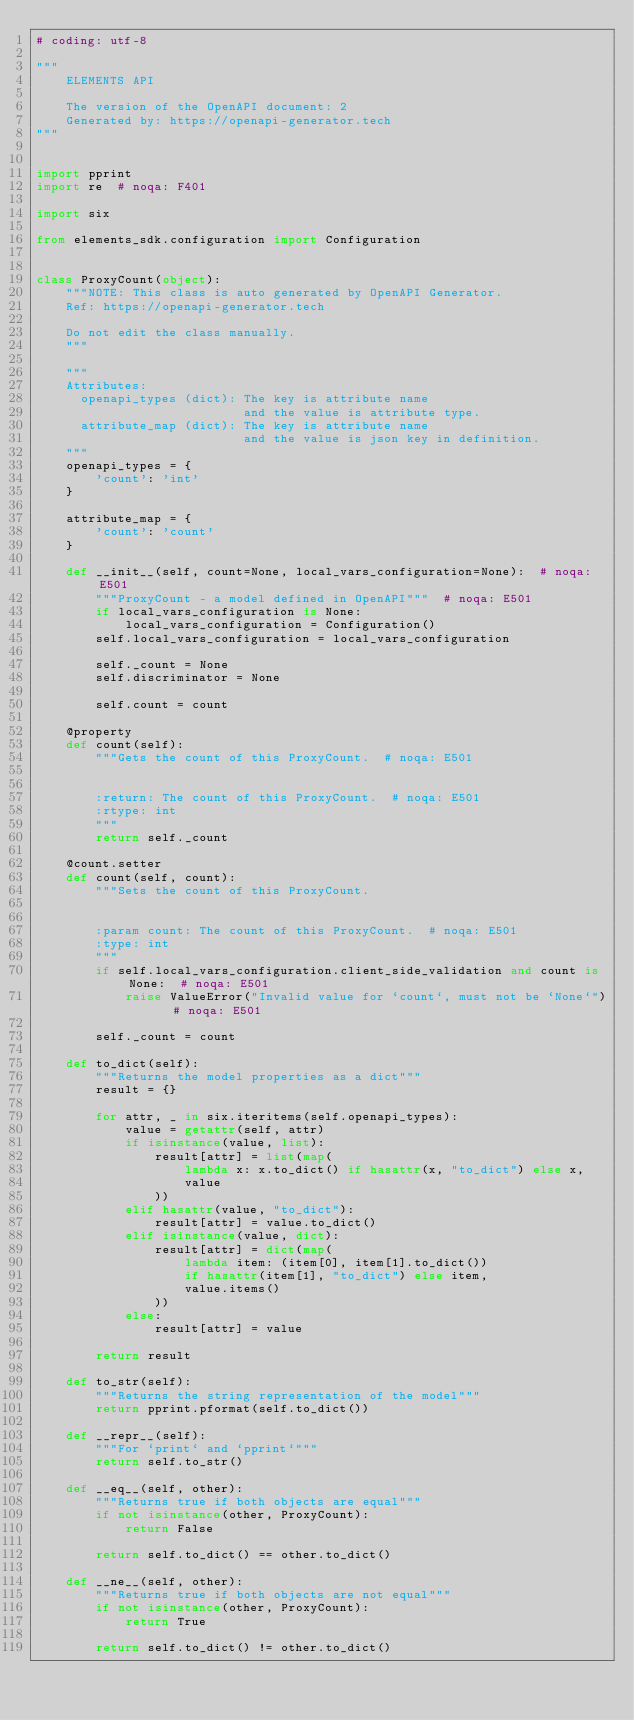Convert code to text. <code><loc_0><loc_0><loc_500><loc_500><_Python_># coding: utf-8

"""
    ELEMENTS API

    The version of the OpenAPI document: 2
    Generated by: https://openapi-generator.tech
"""


import pprint
import re  # noqa: F401

import six

from elements_sdk.configuration import Configuration


class ProxyCount(object):
    """NOTE: This class is auto generated by OpenAPI Generator.
    Ref: https://openapi-generator.tech

    Do not edit the class manually.
    """

    """
    Attributes:
      openapi_types (dict): The key is attribute name
                            and the value is attribute type.
      attribute_map (dict): The key is attribute name
                            and the value is json key in definition.
    """
    openapi_types = {
        'count': 'int'
    }

    attribute_map = {
        'count': 'count'
    }

    def __init__(self, count=None, local_vars_configuration=None):  # noqa: E501
        """ProxyCount - a model defined in OpenAPI"""  # noqa: E501
        if local_vars_configuration is None:
            local_vars_configuration = Configuration()
        self.local_vars_configuration = local_vars_configuration

        self._count = None
        self.discriminator = None

        self.count = count

    @property
    def count(self):
        """Gets the count of this ProxyCount.  # noqa: E501


        :return: The count of this ProxyCount.  # noqa: E501
        :rtype: int
        """
        return self._count

    @count.setter
    def count(self, count):
        """Sets the count of this ProxyCount.


        :param count: The count of this ProxyCount.  # noqa: E501
        :type: int
        """
        if self.local_vars_configuration.client_side_validation and count is None:  # noqa: E501
            raise ValueError("Invalid value for `count`, must not be `None`")  # noqa: E501

        self._count = count

    def to_dict(self):
        """Returns the model properties as a dict"""
        result = {}

        for attr, _ in six.iteritems(self.openapi_types):
            value = getattr(self, attr)
            if isinstance(value, list):
                result[attr] = list(map(
                    lambda x: x.to_dict() if hasattr(x, "to_dict") else x,
                    value
                ))
            elif hasattr(value, "to_dict"):
                result[attr] = value.to_dict()
            elif isinstance(value, dict):
                result[attr] = dict(map(
                    lambda item: (item[0], item[1].to_dict())
                    if hasattr(item[1], "to_dict") else item,
                    value.items()
                ))
            else:
                result[attr] = value

        return result

    def to_str(self):
        """Returns the string representation of the model"""
        return pprint.pformat(self.to_dict())

    def __repr__(self):
        """For `print` and `pprint`"""
        return self.to_str()

    def __eq__(self, other):
        """Returns true if both objects are equal"""
        if not isinstance(other, ProxyCount):
            return False

        return self.to_dict() == other.to_dict()

    def __ne__(self, other):
        """Returns true if both objects are not equal"""
        if not isinstance(other, ProxyCount):
            return True

        return self.to_dict() != other.to_dict()
</code> 